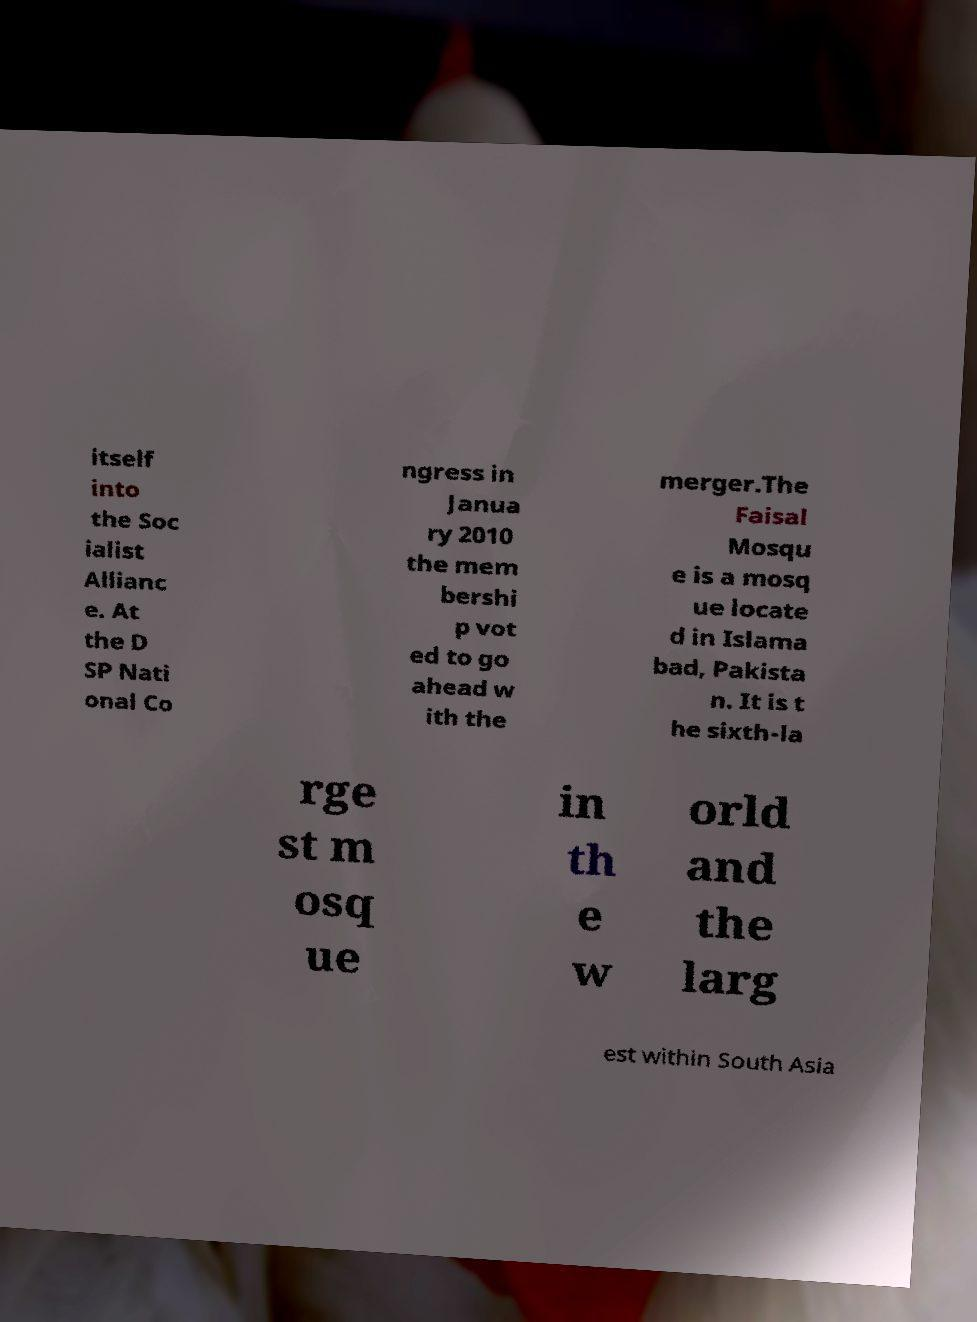For documentation purposes, I need the text within this image transcribed. Could you provide that? itself into the Soc ialist Allianc e. At the D SP Nati onal Co ngress in Janua ry 2010 the mem bershi p vot ed to go ahead w ith the merger.The Faisal Mosqu e is a mosq ue locate d in Islama bad, Pakista n. It is t he sixth-la rge st m osq ue in th e w orld and the larg est within South Asia 